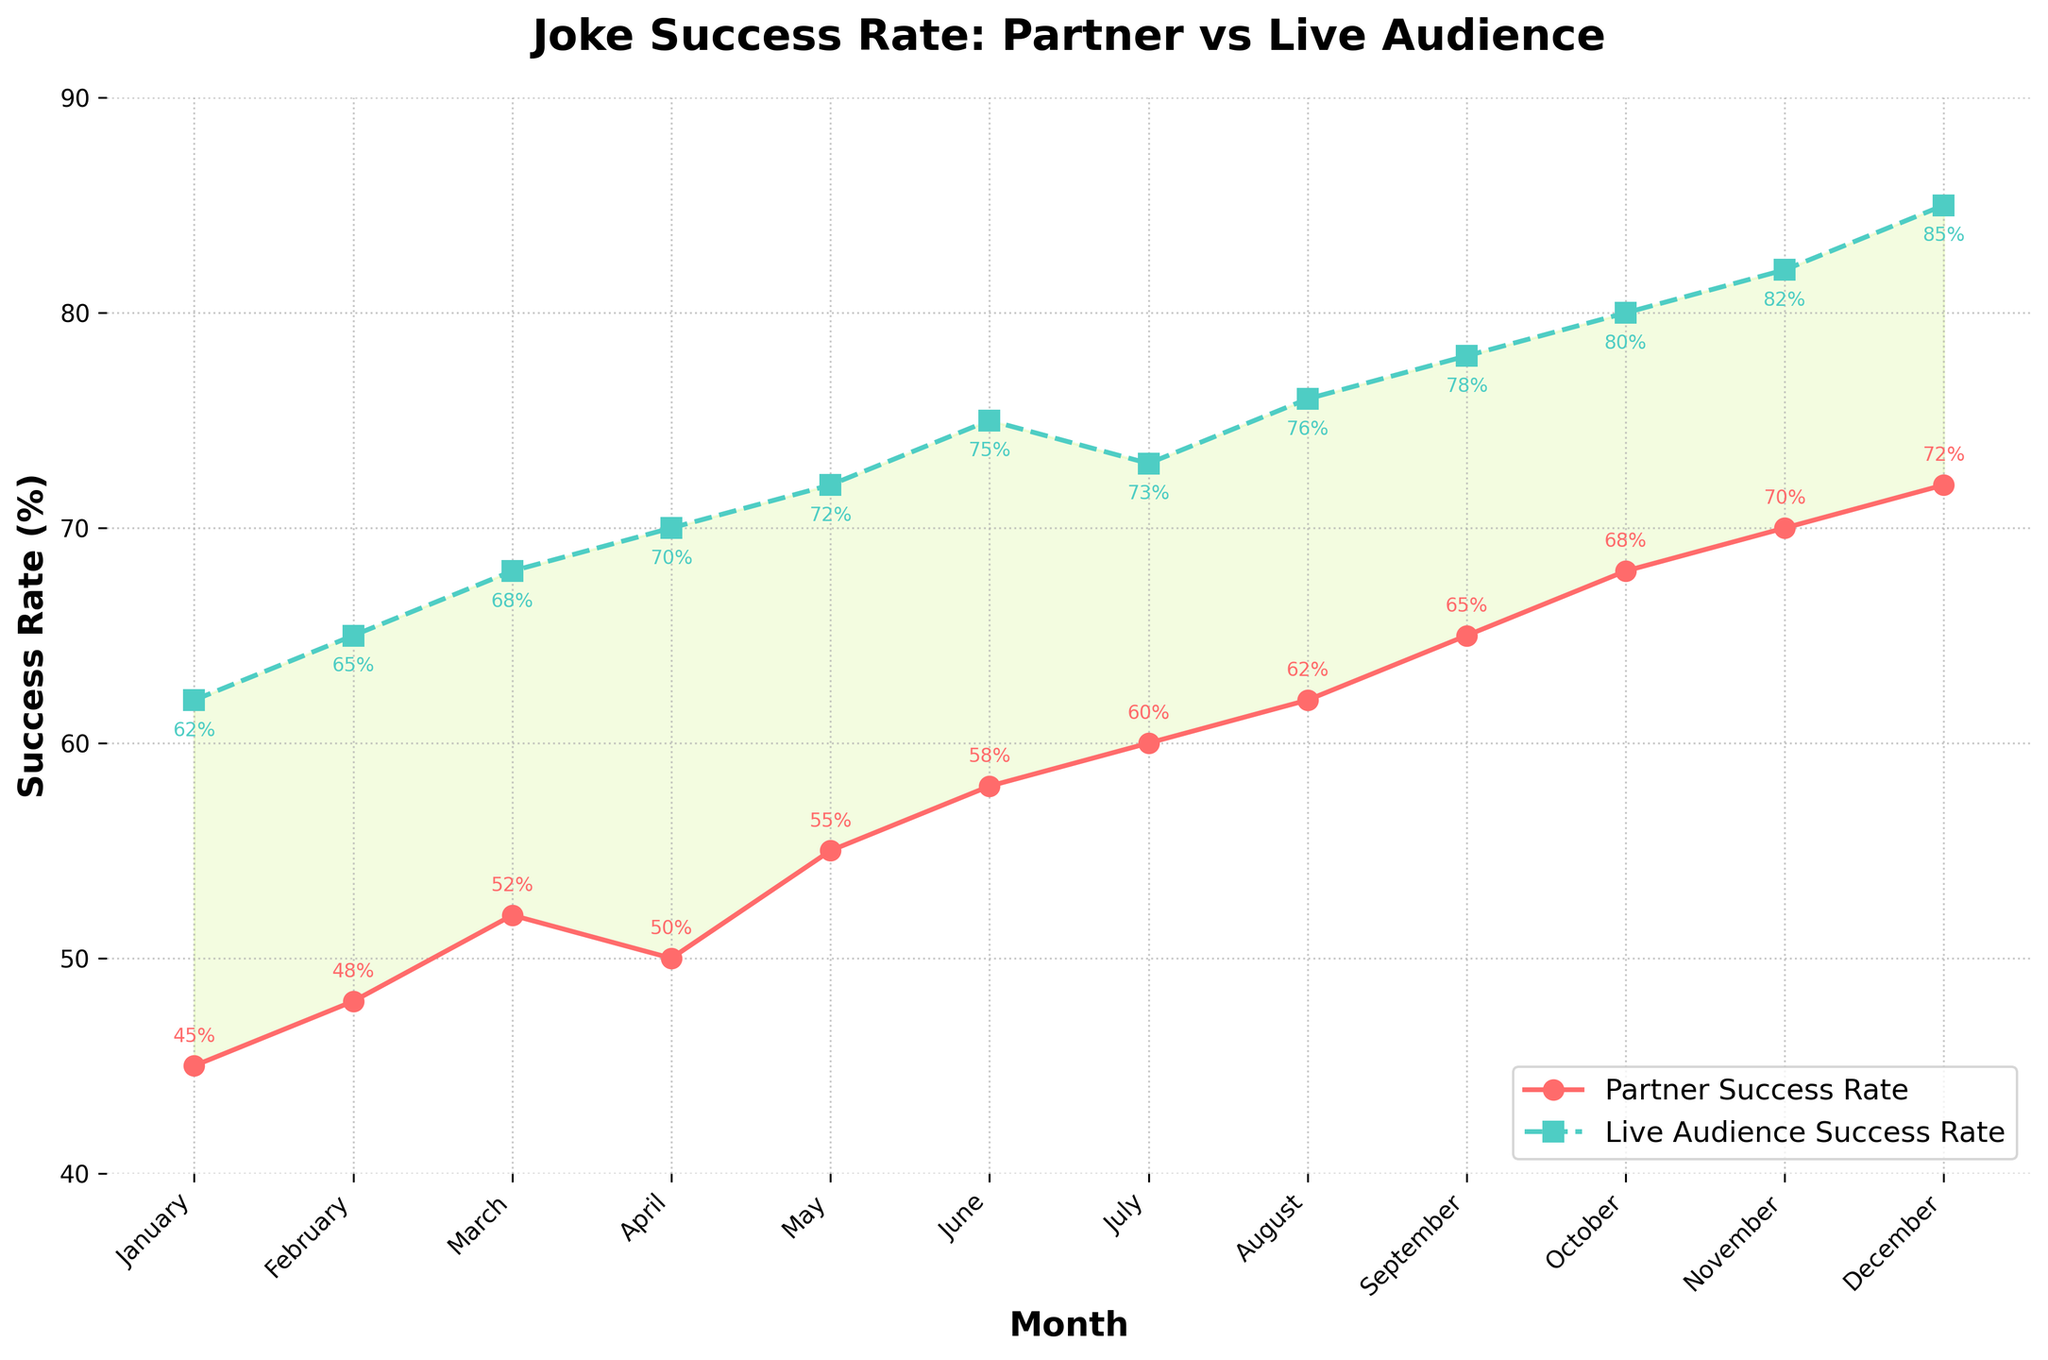What is the success rate difference between the partner and live audience for January? The partner success rate in January is 45% and the live audience success rate is 62%. The difference is calculated by subtracting 45 from 62.
Answer: 17% Which month shows the highest success rate for the partner? The partner success rate gradually increases over the months, with December showing the highest at 72%.
Answer: December In which month do the partner and live audience success rates come closest to each other? By examining the plotted lines, the smallest gap between the partner and live audience success rates appears in July.
Answer: July What is the average live audience success rate over the full year? Sum the live audience success rates (62 + 65 + 68 + 70 + 72 + 75 + 73 + 76 + 78 + 80 + 82 + 85) and divide by 12. The total is 886, and the average is 886 / 12.
Answer: 73.83% By how much does the partner's success rate increase from January to December? The partner success rate increases from 45% in January to 72% in December. The increase is calculated by subtracting 45 from 72.
Answer: 27% Which month shows the greatest increase in the partner success rate from the previous month? To find this, compare the changes between each consecutive pair of months. February to March shows the largest increase, with a rise of 4% (52% - 48%).
Answer: March Between which months does the live audience success rate drop, and by how much? Scanning the live audience success rate plot, we see a drop between June (75%) and July (73%), where it falls by 2%.
Answer: June to July What is the average success rate difference between the partner and live audience over the year? Calculate the difference for each month, sum those differences, and then find the mean. Differences: 17, 17, 16, 20, 17, 17, 13, 14, 13, 12, 12, 13. Sum = 181. Average = 181 / 12.
Answer: 15.08% What is the pattern in the partner success rate over the year? The partner success rate generally increases steadily over the year, from January to December.
Answer: Increasing steadily 